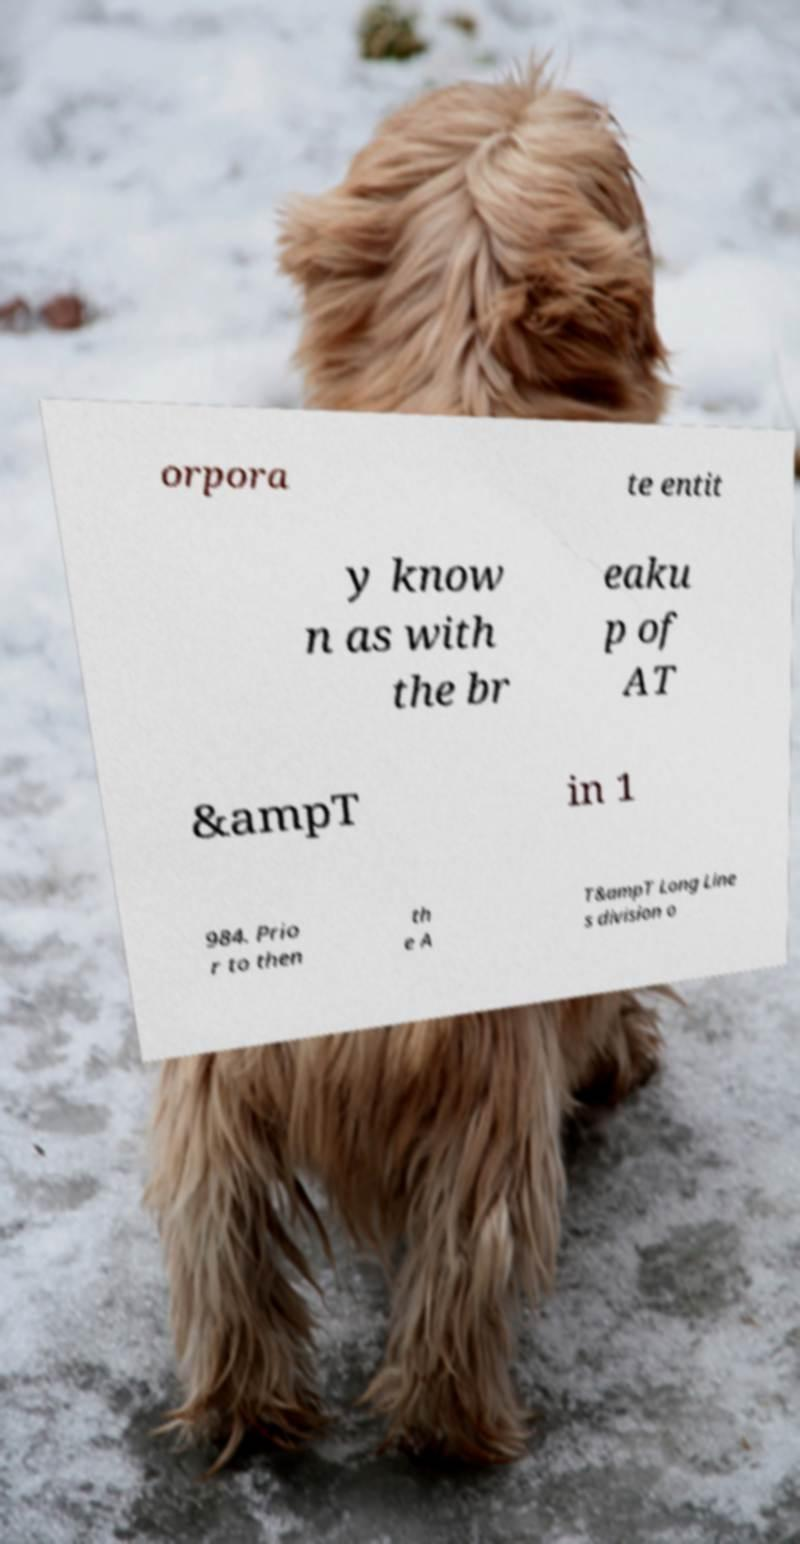Please read and relay the text visible in this image. What does it say? orpora te entit y know n as with the br eaku p of AT &ampT in 1 984. Prio r to then th e A T&ampT Long Line s division o 